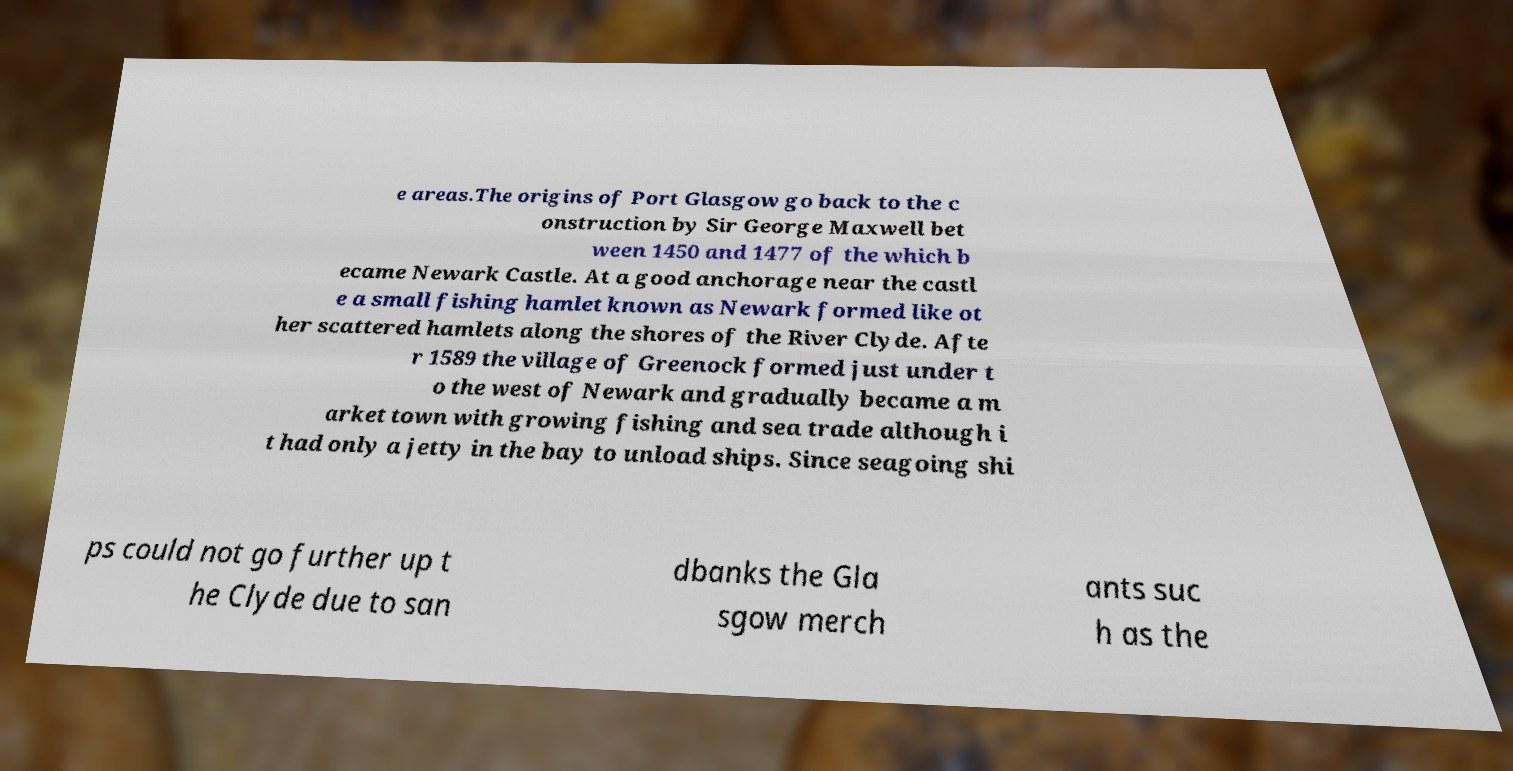What messages or text are displayed in this image? I need them in a readable, typed format. e areas.The origins of Port Glasgow go back to the c onstruction by Sir George Maxwell bet ween 1450 and 1477 of the which b ecame Newark Castle. At a good anchorage near the castl e a small fishing hamlet known as Newark formed like ot her scattered hamlets along the shores of the River Clyde. Afte r 1589 the village of Greenock formed just under t o the west of Newark and gradually became a m arket town with growing fishing and sea trade although i t had only a jetty in the bay to unload ships. Since seagoing shi ps could not go further up t he Clyde due to san dbanks the Gla sgow merch ants suc h as the 